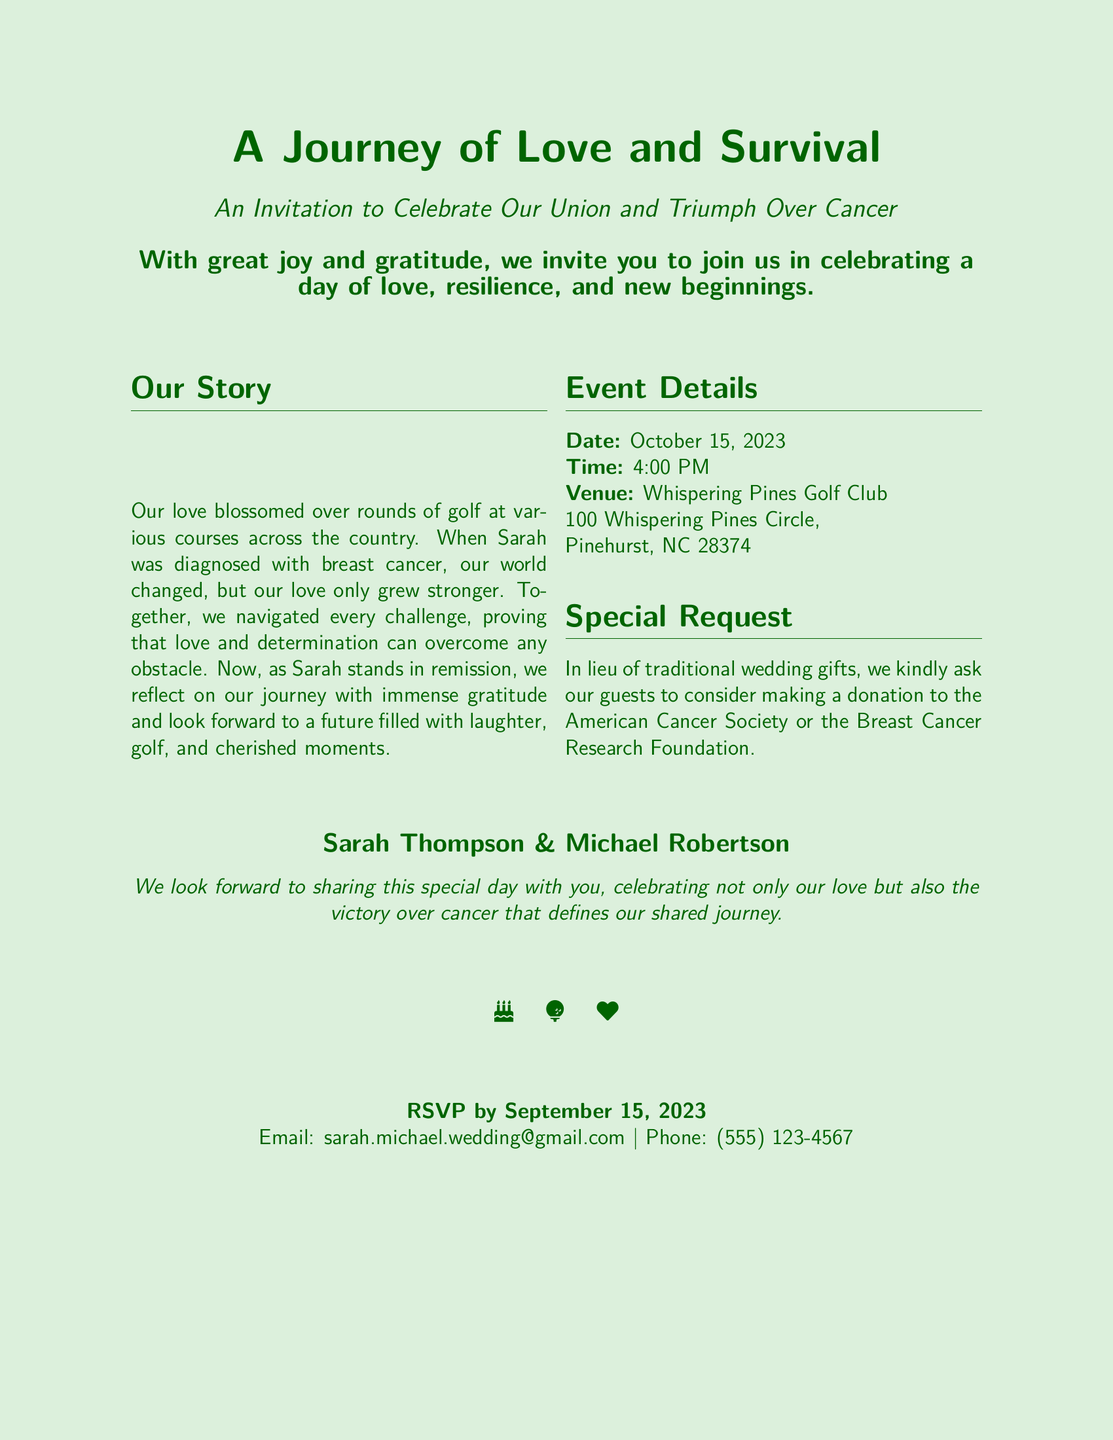What is the date of the wedding? The date mentioned in the document is explicitly stated under the Event Details section.
Answer: October 15, 2023 What is the venue for the celebration? The venue is specified in the Event Details section of the document.
Answer: Whispering Pines Golf Club Who are the couple getting married? The couple's names are clearly mentioned at the bottom of the document.
Answer: Sarah Thompson & Michael Robertson What time is the wedding scheduled to start? The time is included in the Event Details section, listing the start of the wedding.
Answer: 4:00 PM What special request is mentioned in the invitation? The special request is noted under the Special Request section of the document.
Answer: Donations to the American Cancer Society or the Breast Cancer Research Foundation What theme is emphasized in the invitation? The theme is highlighted in the title and introduction of the invitation.
Answer: Love and survival By when should guests RSVP? The RSVP deadline is specified towards the end of the document.
Answer: September 15, 2023 What personal experience is shared in the couple's story? The couple’s story highlights a significant life event described in the document.
Answer: Breast cancer diagnosis 